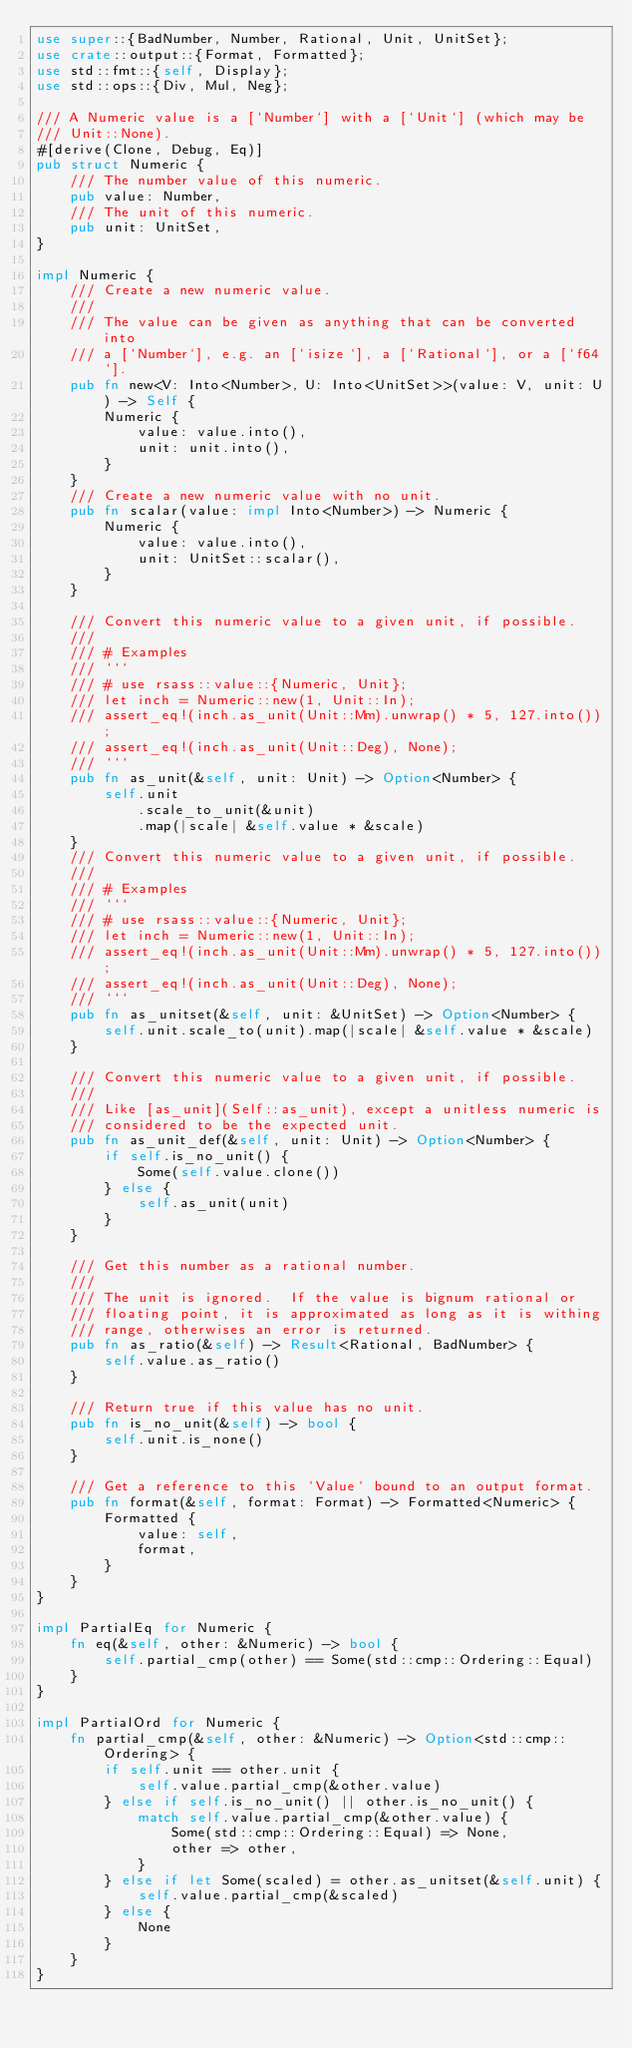<code> <loc_0><loc_0><loc_500><loc_500><_Rust_>use super::{BadNumber, Number, Rational, Unit, UnitSet};
use crate::output::{Format, Formatted};
use std::fmt::{self, Display};
use std::ops::{Div, Mul, Neg};

/// A Numeric value is a [`Number`] with a [`Unit`] (which may be
/// Unit::None).
#[derive(Clone, Debug, Eq)]
pub struct Numeric {
    /// The number value of this numeric.
    pub value: Number,
    /// The unit of this numeric.
    pub unit: UnitSet,
}

impl Numeric {
    /// Create a new numeric value.
    ///
    /// The value can be given as anything that can be converted into
    /// a [`Number`], e.g. an [`isize`], a [`Rational`], or a [`f64`].
    pub fn new<V: Into<Number>, U: Into<UnitSet>>(value: V, unit: U) -> Self {
        Numeric {
            value: value.into(),
            unit: unit.into(),
        }
    }
    /// Create a new numeric value with no unit.
    pub fn scalar(value: impl Into<Number>) -> Numeric {
        Numeric {
            value: value.into(),
            unit: UnitSet::scalar(),
        }
    }

    /// Convert this numeric value to a given unit, if possible.
    ///
    /// # Examples
    /// ```
    /// # use rsass::value::{Numeric, Unit};
    /// let inch = Numeric::new(1, Unit::In);
    /// assert_eq!(inch.as_unit(Unit::Mm).unwrap() * 5, 127.into());
    /// assert_eq!(inch.as_unit(Unit::Deg), None);
    /// ```
    pub fn as_unit(&self, unit: Unit) -> Option<Number> {
        self.unit
            .scale_to_unit(&unit)
            .map(|scale| &self.value * &scale)
    }
    /// Convert this numeric value to a given unit, if possible.
    ///
    /// # Examples
    /// ```
    /// # use rsass::value::{Numeric, Unit};
    /// let inch = Numeric::new(1, Unit::In);
    /// assert_eq!(inch.as_unit(Unit::Mm).unwrap() * 5, 127.into());
    /// assert_eq!(inch.as_unit(Unit::Deg), None);
    /// ```
    pub fn as_unitset(&self, unit: &UnitSet) -> Option<Number> {
        self.unit.scale_to(unit).map(|scale| &self.value * &scale)
    }

    /// Convert this numeric value to a given unit, if possible.
    ///
    /// Like [as_unit](Self::as_unit), except a unitless numeric is
    /// considered to be the expected unit.
    pub fn as_unit_def(&self, unit: Unit) -> Option<Number> {
        if self.is_no_unit() {
            Some(self.value.clone())
        } else {
            self.as_unit(unit)
        }
    }

    /// Get this number as a rational number.
    ///
    /// The unit is ignored.  If the value is bignum rational or
    /// floating point, it is approximated as long as it is withing
    /// range, otherwises an error is returned.
    pub fn as_ratio(&self) -> Result<Rational, BadNumber> {
        self.value.as_ratio()
    }

    /// Return true if this value has no unit.
    pub fn is_no_unit(&self) -> bool {
        self.unit.is_none()
    }

    /// Get a reference to this `Value` bound to an output format.
    pub fn format(&self, format: Format) -> Formatted<Numeric> {
        Formatted {
            value: self,
            format,
        }
    }
}

impl PartialEq for Numeric {
    fn eq(&self, other: &Numeric) -> bool {
        self.partial_cmp(other) == Some(std::cmp::Ordering::Equal)
    }
}

impl PartialOrd for Numeric {
    fn partial_cmp(&self, other: &Numeric) -> Option<std::cmp::Ordering> {
        if self.unit == other.unit {
            self.value.partial_cmp(&other.value)
        } else if self.is_no_unit() || other.is_no_unit() {
            match self.value.partial_cmp(&other.value) {
                Some(std::cmp::Ordering::Equal) => None,
                other => other,
            }
        } else if let Some(scaled) = other.as_unitset(&self.unit) {
            self.value.partial_cmp(&scaled)
        } else {
            None
        }
    }
}
</code> 